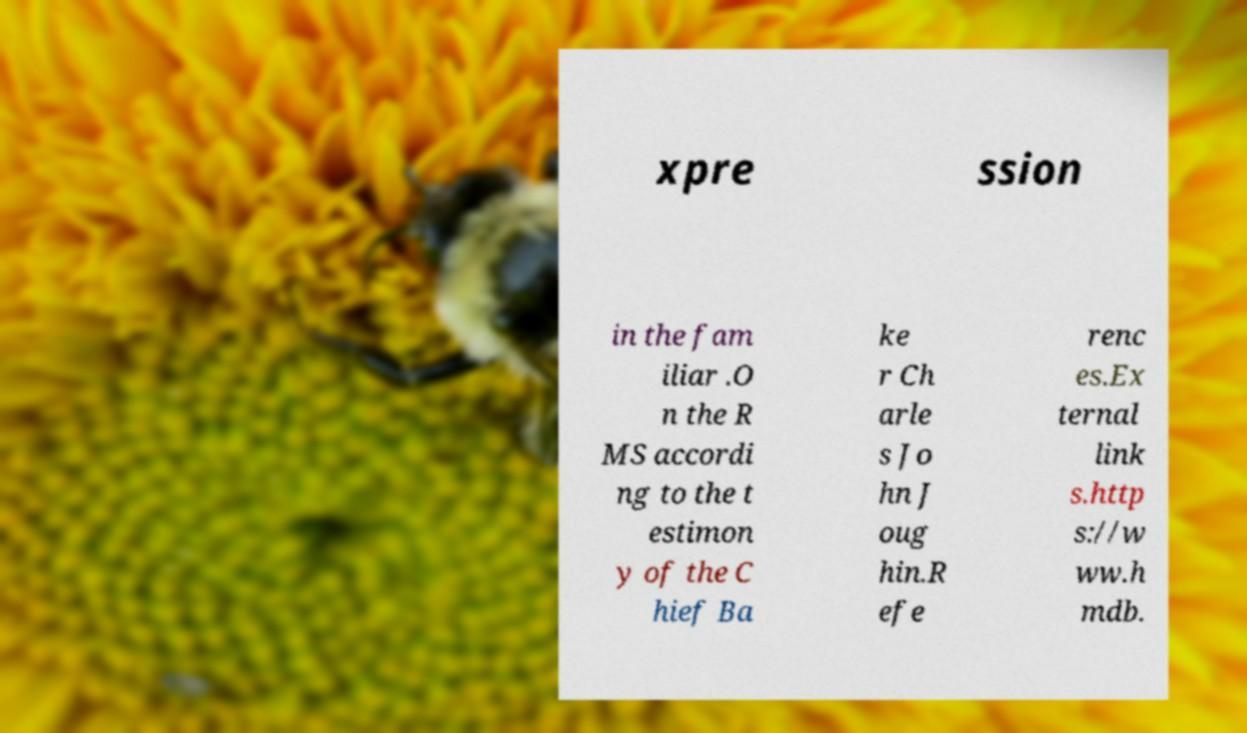Please read and relay the text visible in this image. What does it say? xpre ssion in the fam iliar .O n the R MS accordi ng to the t estimon y of the C hief Ba ke r Ch arle s Jo hn J oug hin.R efe renc es.Ex ternal link s.http s://w ww.h mdb. 